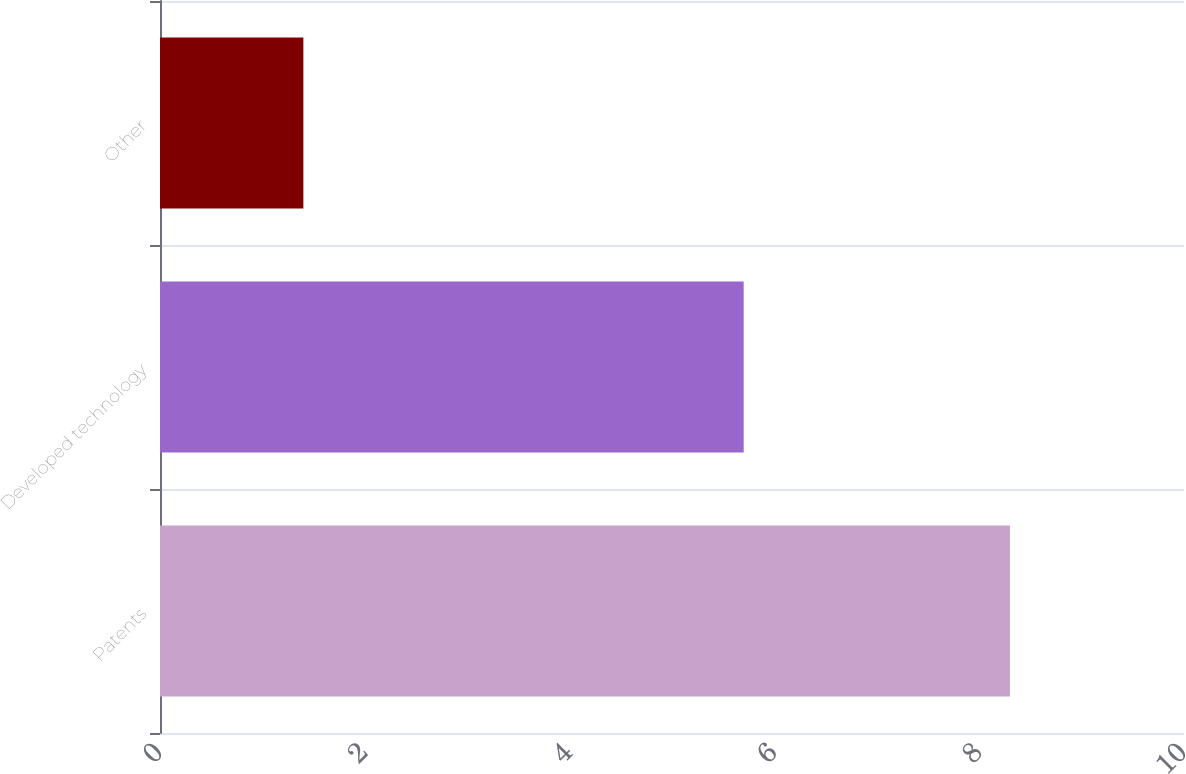Convert chart. <chart><loc_0><loc_0><loc_500><loc_500><bar_chart><fcel>Patents<fcel>Developed technology<fcel>Other<nl><fcel>8.3<fcel>5.7<fcel>1.4<nl></chart> 